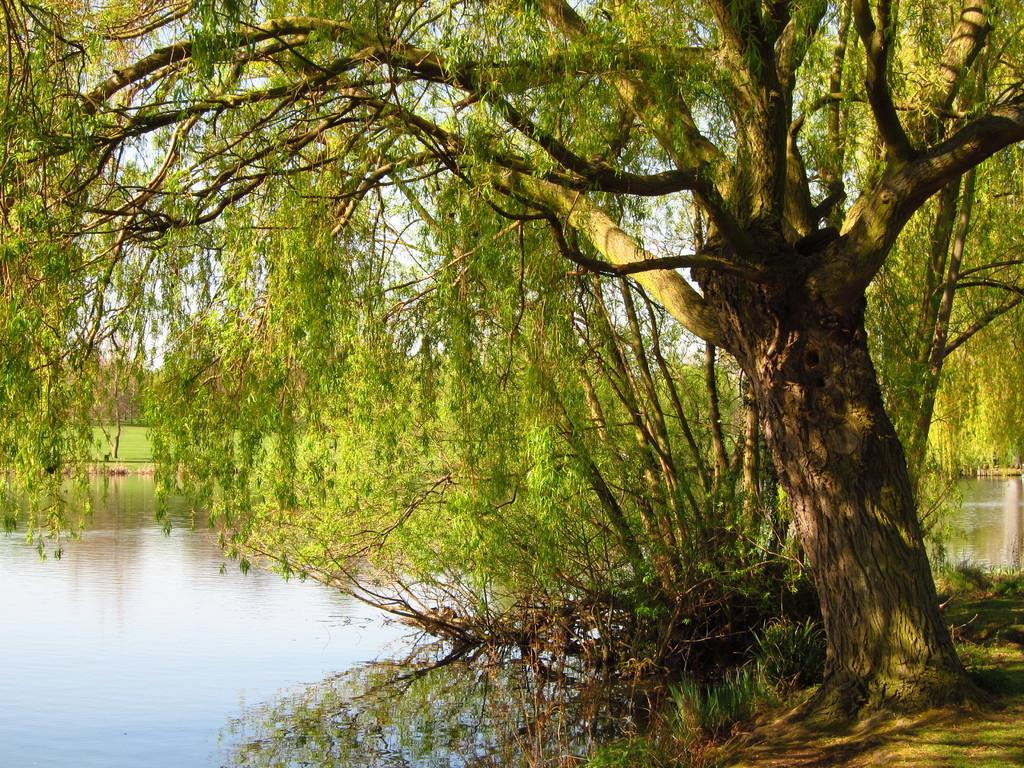What type of vegetation can be seen in the image? There are trees in the image. What else can be seen in the image besides trees? There is water and grass visible in the image. What is visible in the background of the image? The sky is visible behind the trees in the image. How many beads are hanging from the trees in the image? There are no beads present in the image; it features trees, water, grass, and the sky. What type of bike can be seen in the image? There is no bike present in the image. 